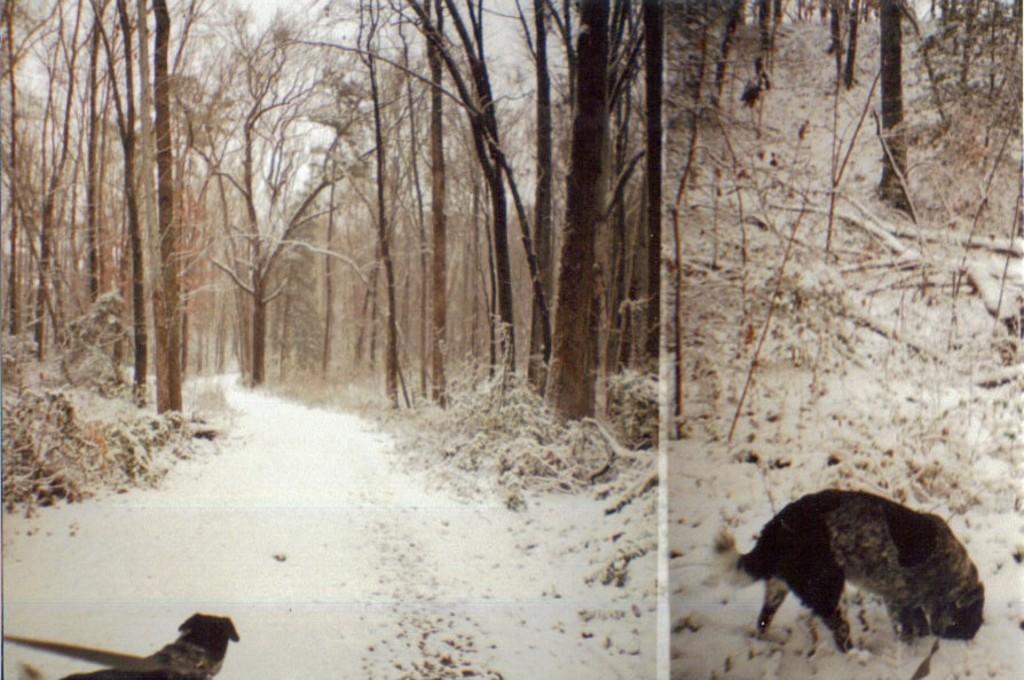Describe this image in one or two sentences. This is a collage picture. Here we can a dog. This is snow. In the background there are trees and sky. 